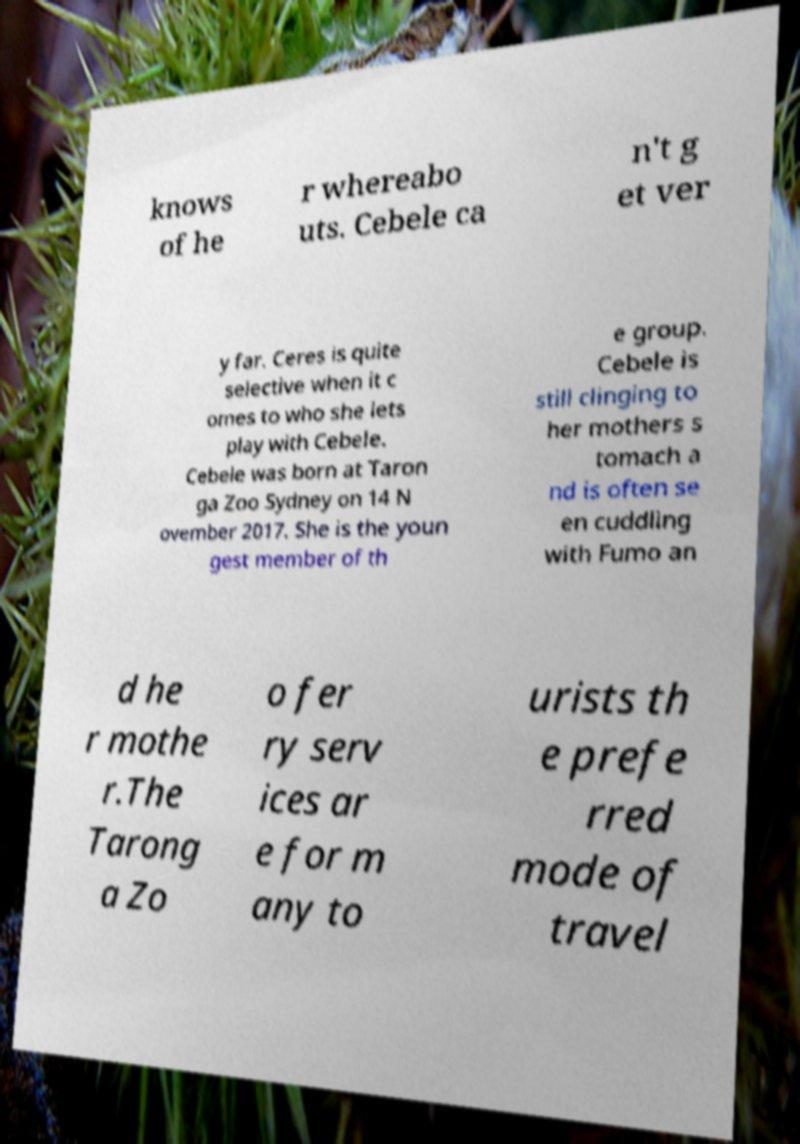I need the written content from this picture converted into text. Can you do that? knows of he r whereabo uts. Cebele ca n't g et ver y far. Ceres is quite selective when it c omes to who she lets play with Cebele. Cebele was born at Taron ga Zoo Sydney on 14 N ovember 2017. She is the youn gest member of th e group. Cebele is still clinging to her mothers s tomach a nd is often se en cuddling with Fumo an d he r mothe r.The Tarong a Zo o fer ry serv ices ar e for m any to urists th e prefe rred mode of travel 